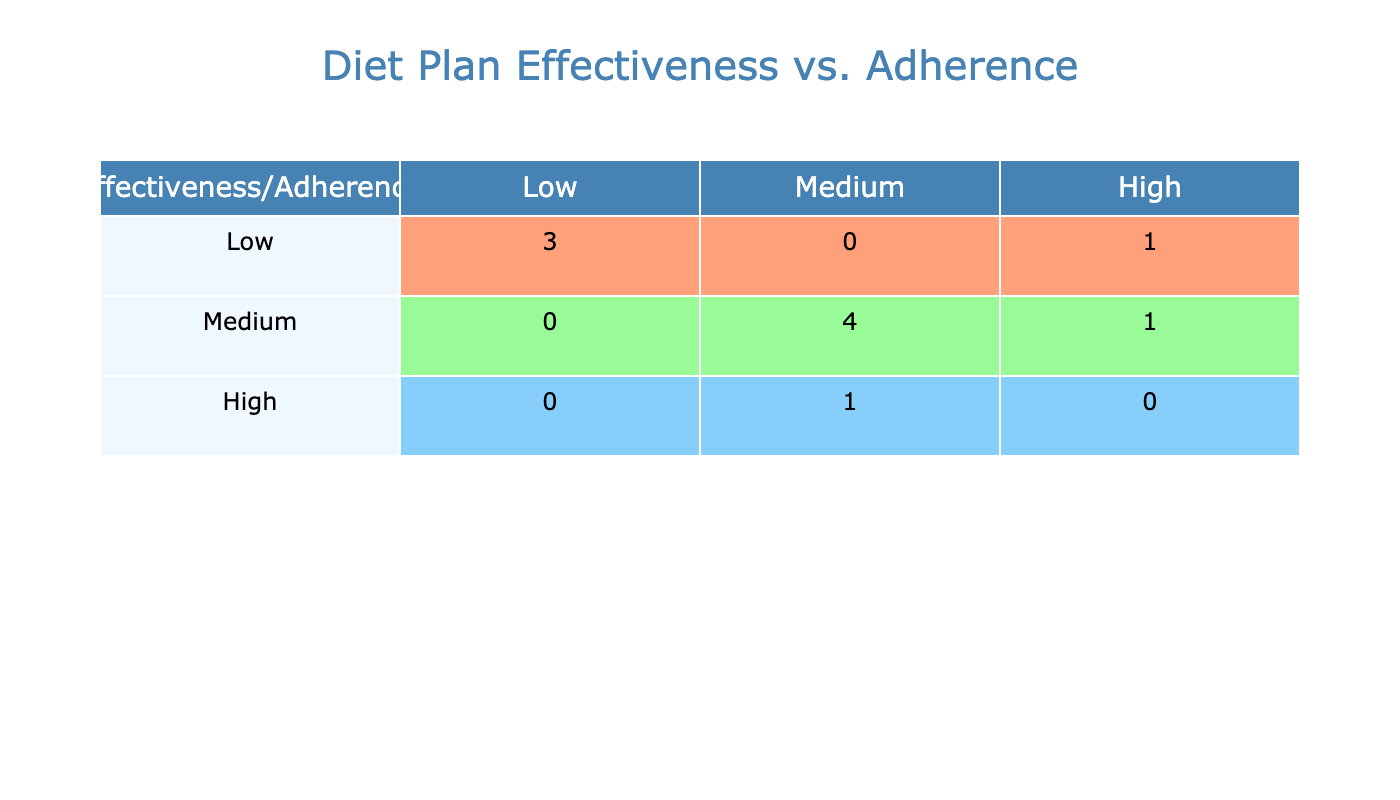What is the effectiveness rate of the Vegan Diet? According to the table, the Vegan Diet has an effectiveness rate of 78%. This information is directly visible in the row corresponding to the Vegan Diet under the Effectiveness Rate column.
Answer: 78% How many diet plans have a high effectiveness rate? Looking at the effectiveness categories, only the Mediterranean Diet and the DASH Diet fall under the 'High' category, which corresponds to effectiveness rates above 85%. There are 2 diet plans in total.
Answer: 2 Which diet plan has the highest adherence rate? The Weight Watchers diet plan has the highest adherence rate of 85%, which is indicated in the Adherence Rate column. It can be found in the row for Weight Watchers.
Answer: 85% Is the adherence rate of the Paleo Diet low? The Paleo Diet has an adherence rate of 65%, which falls under the 'Low' adherence category as defined in the table's categorization. Therefore, this statement is true.
Answer: Yes What is the difference between the effectiveness rates of the Mediterranean Diet and the Ketogenic Diet? The Mediterranean Diet has an effectiveness rate of 87% while the Ketogenic Diet has 75%. The difference is calculated by subtracting the latter from the former: 87% - 75% = 12%.
Answer: 12% How many diet plans have both high effectiveness and adherence rates? Upon reviewing the table, the only diet plan that qualifies for both high categories (effectiveness and adherence) is the Mediterranean Diet. Thus, there is 1 diet plan with these characteristics.
Answer: 1 What is the average adherence rate of all diet plans classified as medium effectiveness? The diet plans with a medium effectiveness rate are DASH Diet (70%), Weight Watchers (85%), Intermittent Fasting (68%), and Flexitarian Diet (80%). First, we sum these rates: 70 + 85 + 68 + 80 = 303. Then we divide by the number of plans, which is 4: 303 / 4 = 75.75%. Thus, the average adherence rate is 75.75%.
Answer: 75.75% Does the Ketogenic Diet have a higher adherence rate than the Atkins Diet? The Ketogenic Diet has an adherence rate of 60%, while the Atkins Diet has an adherence rate of 59%. Since 60% is greater than 59%, the answer is yes, the Ketogenic Diet does have a higher adherence rate.
Answer: Yes 